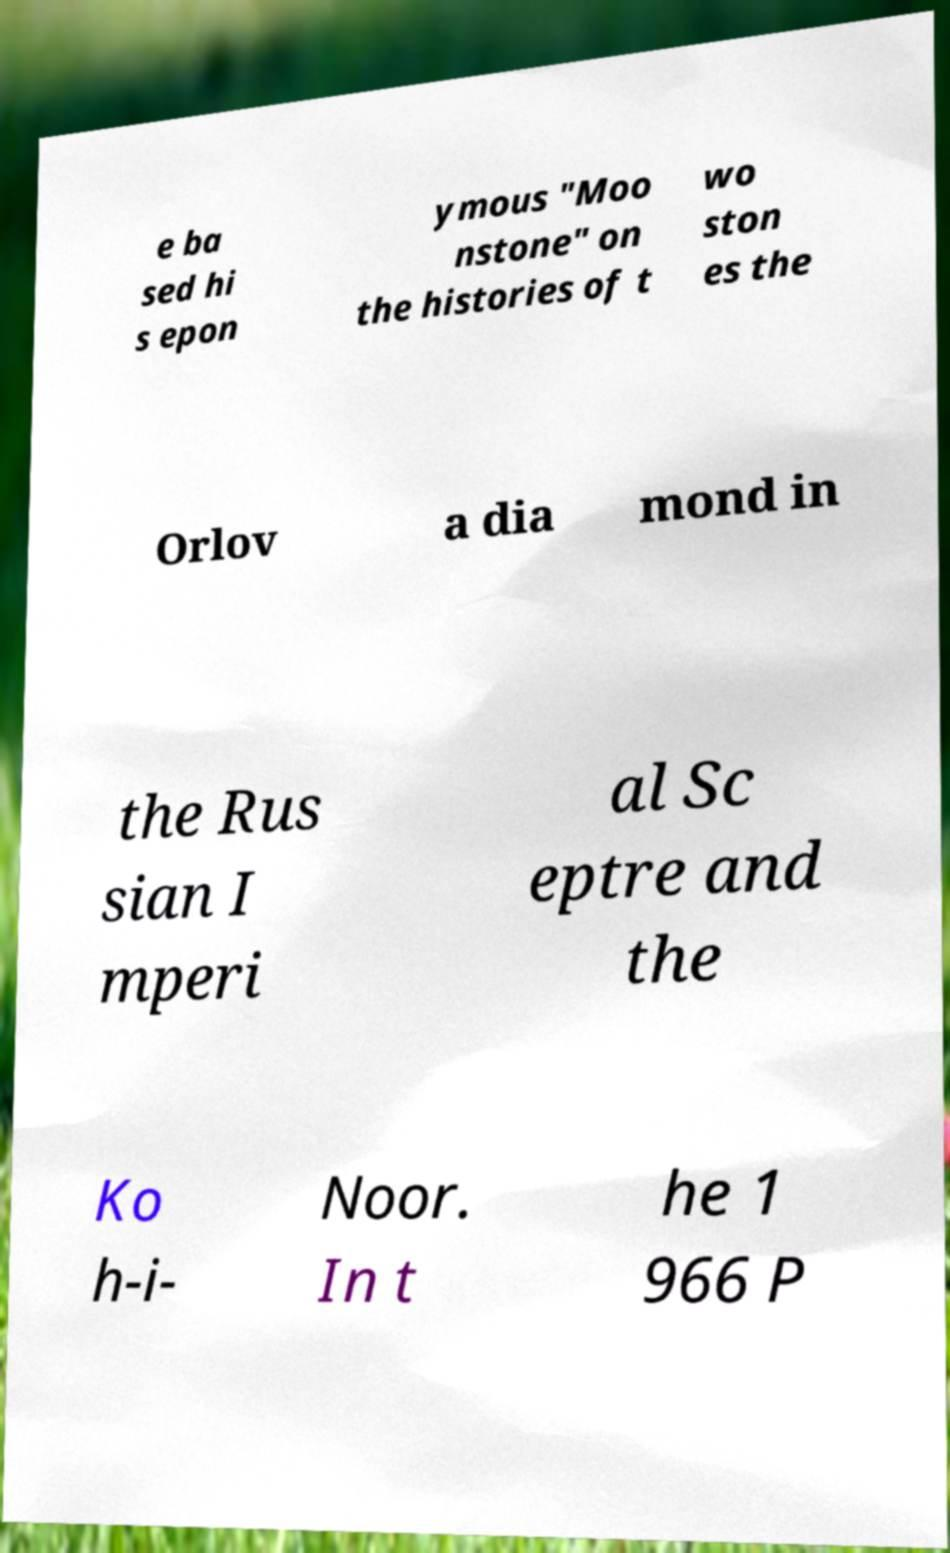Could you assist in decoding the text presented in this image and type it out clearly? e ba sed hi s epon ymous "Moo nstone" on the histories of t wo ston es the Orlov a dia mond in the Rus sian I mperi al Sc eptre and the Ko h-i- Noor. In t he 1 966 P 